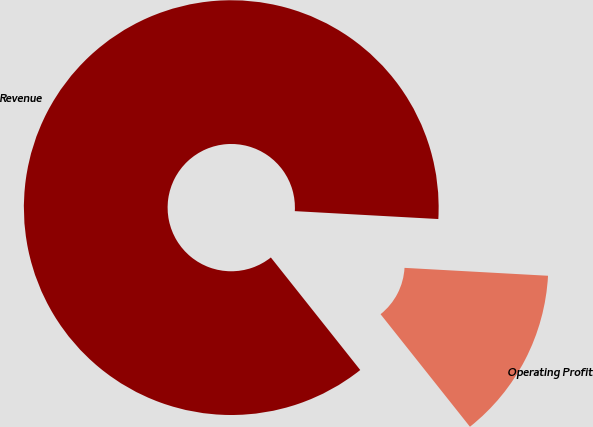Convert chart to OTSL. <chart><loc_0><loc_0><loc_500><loc_500><pie_chart><fcel>Revenue<fcel>Operating Profit<nl><fcel>86.56%<fcel>13.44%<nl></chart> 